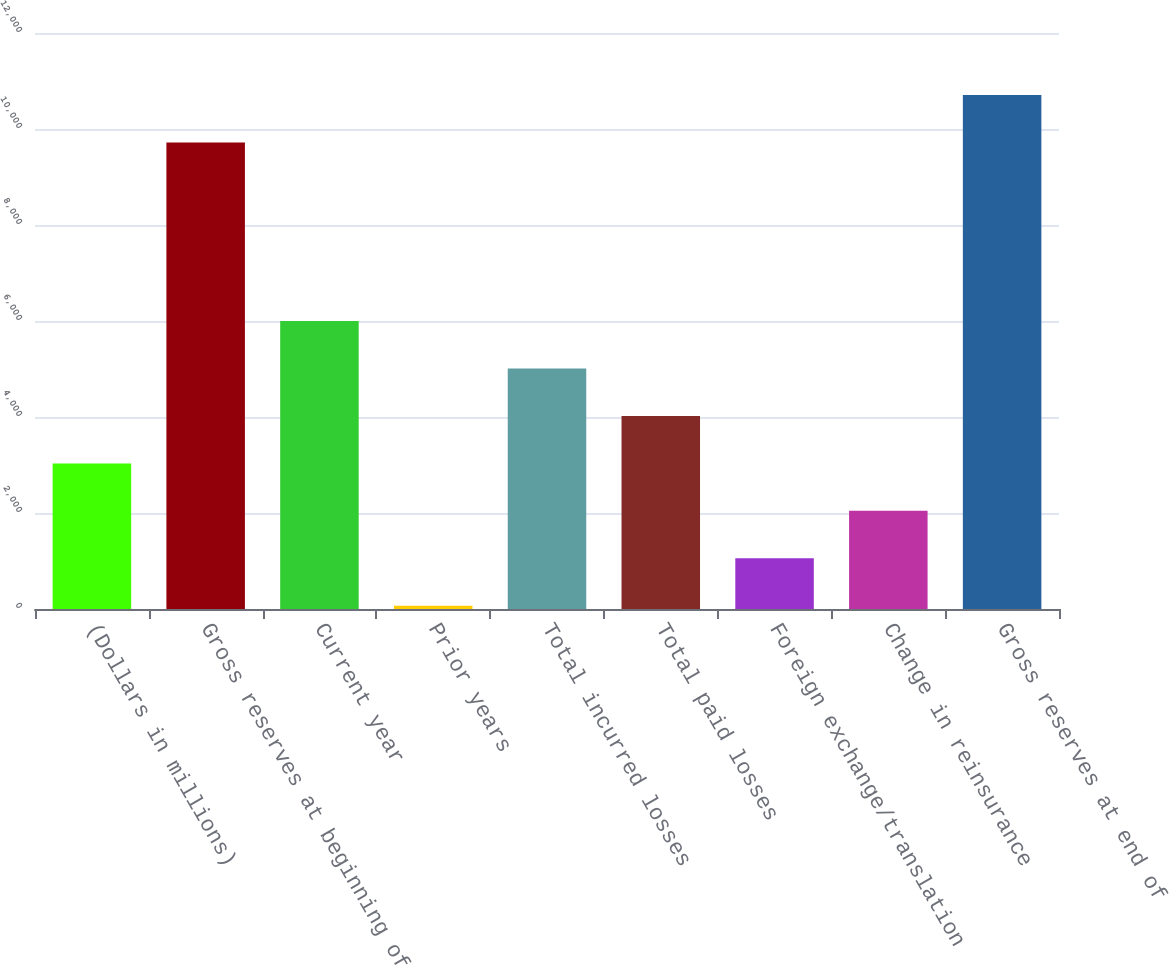<chart> <loc_0><loc_0><loc_500><loc_500><bar_chart><fcel>(Dollars in millions)<fcel>Gross reserves at beginning of<fcel>Current year<fcel>Prior years<fcel>Total incurred losses<fcel>Total paid losses<fcel>Foreign exchange/translation<fcel>Change in reinsurance<fcel>Gross reserves at end of<nl><fcel>3033.56<fcel>9720.8<fcel>5998.52<fcel>68.6<fcel>5010.2<fcel>4021.88<fcel>1056.92<fcel>2045.24<fcel>10709.1<nl></chart> 